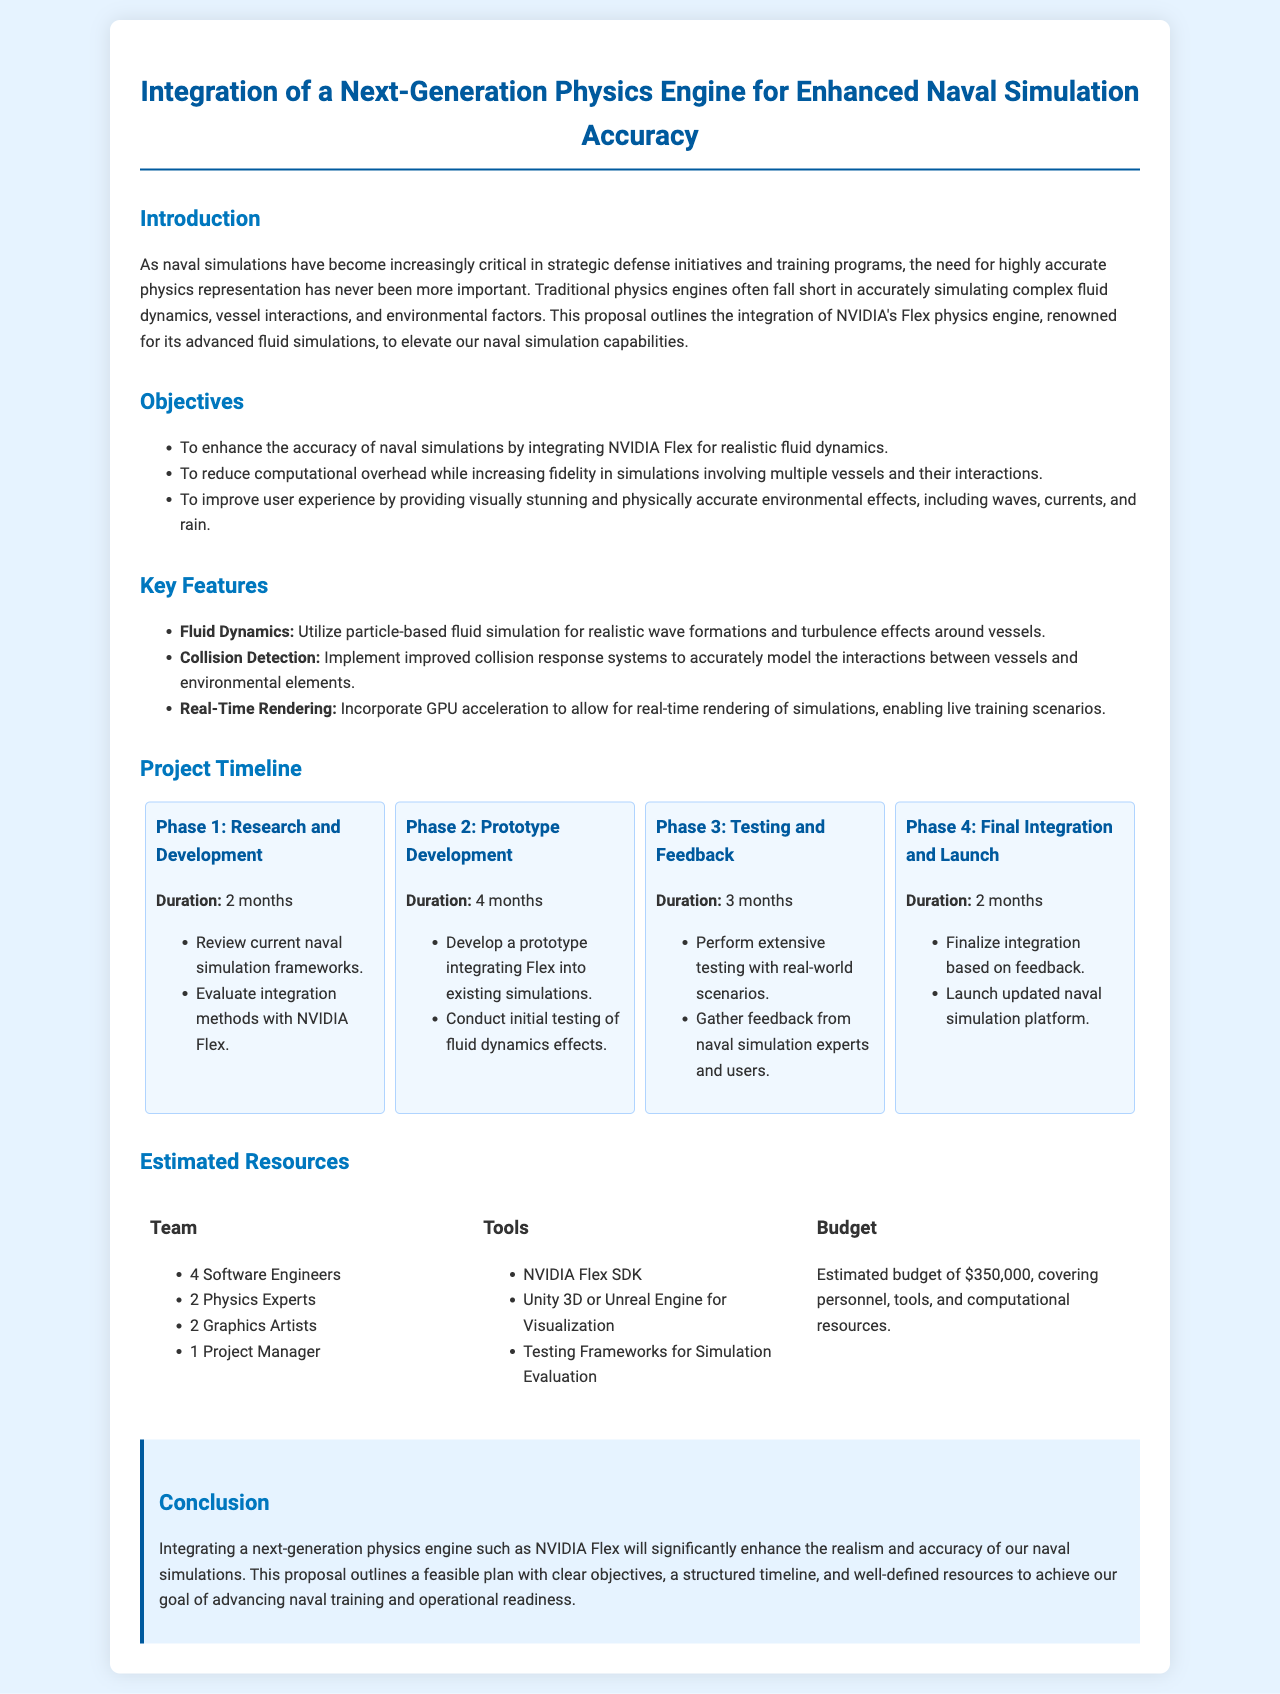What is the name of the physics engine to be integrated? The document mentions the integration of NVIDIA's Flex physics engine.
Answer: NVIDIA Flex How many software engineers are estimated for the project? The resources section states that 4 software engineers will be part of the project team.
Answer: 4 What is the estimated budget for the project? The budget mentioned in the resources section is $350,000, which covers various costs.
Answer: $350,000 What is the duration of the Research and Development phase? The timeline indicates that the Research and Development phase will last for 2 months.
Answer: 2 months What key feature involves utilizing particle-based fluid simulation? The key feature related to this is "Fluid Dynamics," enhancing the accuracy of naval simulations.
Answer: Fluid Dynamics In which phase is initial testing of fluid dynamics effects conducted? The prototype development phase includes conducting initial testing of fluid dynamics effects.
Answer: Phase 2: Prototype Development How many phases are outlined in the project timeline? The document details four distinct phases in the project timeline.
Answer: 4 Which role is included in the project team apart from software engineers? The document lists physics experts as part of the project team, alongside software engineers.
Answer: Physics Experts What is one of the tools listed for visualization? The resources section mentions either Unity 3D or Unreal Engine as tools for visualization.
Answer: Unity 3D or Unreal Engine 